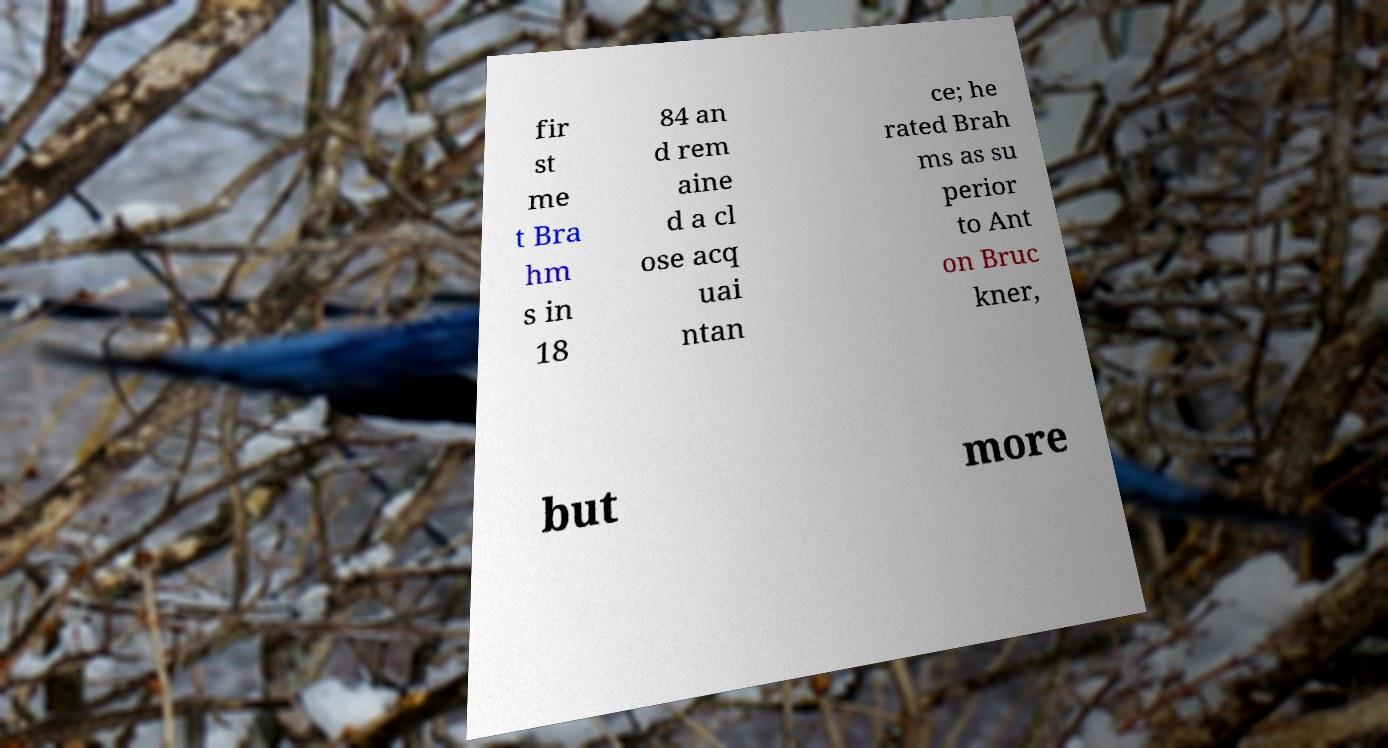Please identify and transcribe the text found in this image. fir st me t Bra hm s in 18 84 an d rem aine d a cl ose acq uai ntan ce; he rated Brah ms as su perior to Ant on Bruc kner, but more 